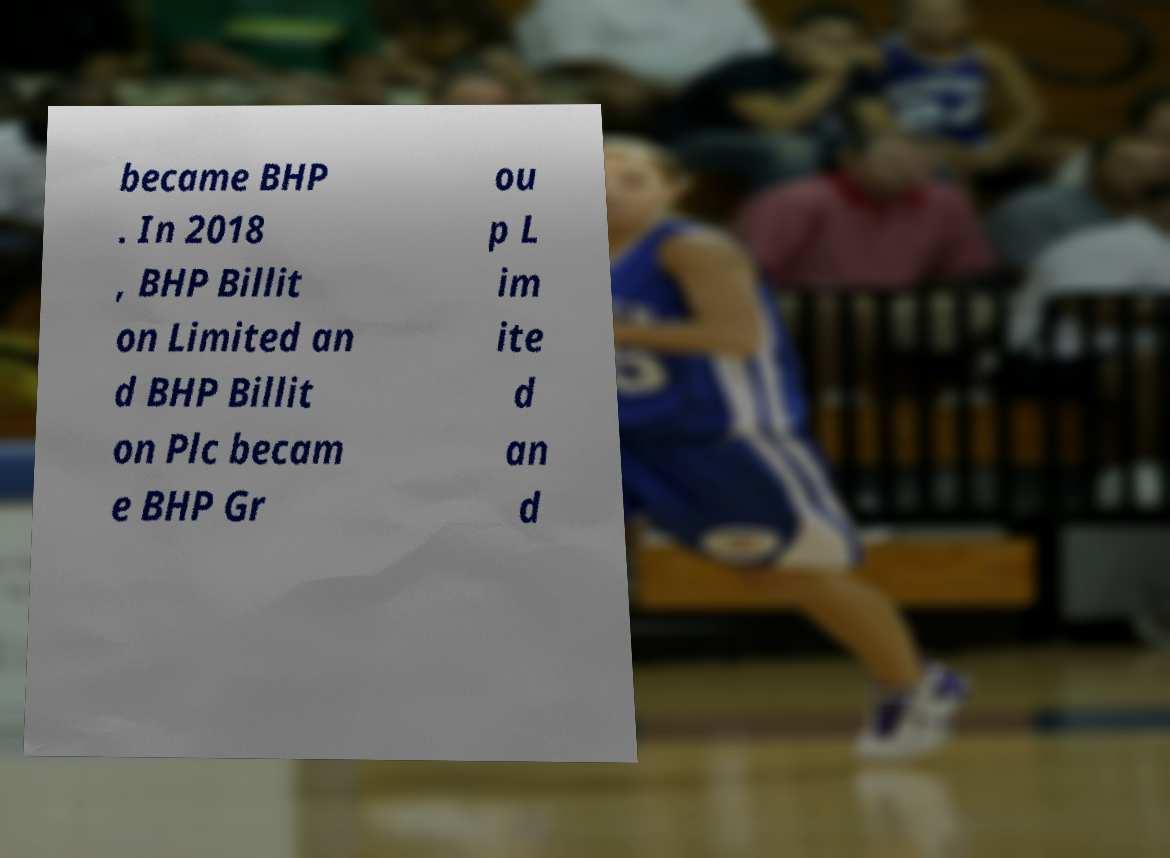Could you extract and type out the text from this image? became BHP . In 2018 , BHP Billit on Limited an d BHP Billit on Plc becam e BHP Gr ou p L im ite d an d 